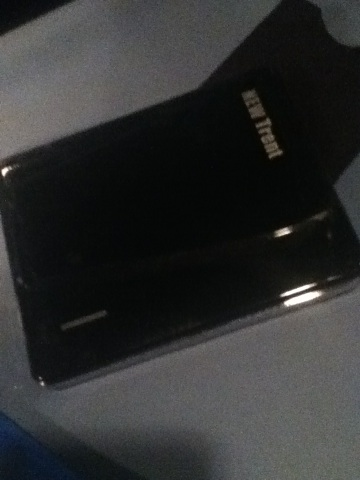Imagine if this device could talk. What kind of stories would it tell? If this external hard drive could talk, it might tell stories of the countless pieces of data it safeguards daily—a photo album's worth of cherished memories, critical work documents saved just in time, and massive collections of music and movies. It could narrate the journey it has traveled from factory, to store shelf, to its current owner's desk, or recall its role in a critical data recovery operation that saved important files from a failing computer. 